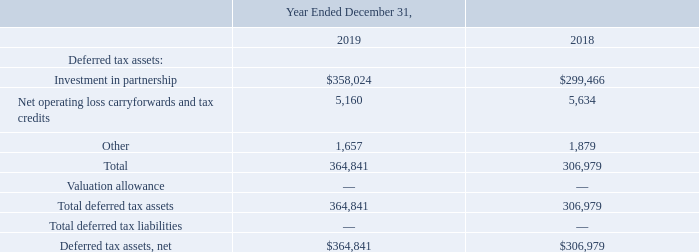GreenSky, Inc. NOTES TO CONSOLIDATED FINANCIAL STATEMENTS — (Continued) (United States Dollars in thousands, except per share data, unless otherwise stated)
Details of the Company’s deferred tax assets and liabilities are as follows:
As of December 31, 2019, the Company had net operating loss carryforwards (“NOLs”) of $4.7 million, of which approximately $3.9 million have an indefinite life. NOLs of $0.8 million will begin to expire in 2030. As of December 31, 2019, the Company had federal and state tax credit carryforwards of $0.2 million and $0.5 million, respectively, which will begin to expire in 2028 and 2038. The Company believes as of December 31, 2019, it is more likely than not that the results of future operations will generate sufficient taxable income to realize the NOLs and tax credits and, as such, no valuation allowance was recorded.
What was the Company's net operating loss carryforwards as of December 31, 2019?
Answer scale should be: million. 4.7. What was the company's investment in partnership in 2018?
Answer scale should be: thousand. 299,466. Which years does the table provide information for the Company’s deferred tax assets and liabilities? 2019, 2018. How many years did Investment in partnership exceed $300,000 thousand? 2019
Answer: 1. What was the change in the the Total deferred tax assets between 2018 and 2019?
Answer scale should be: thousand. 364,841-306,979
Answer: 57862. What was the change in the Net operating loss carryforwards and tax credits between 2018 and 2019?
Answer scale should be: percent. (5,160-5,634)/5,634
Answer: -8.41. 